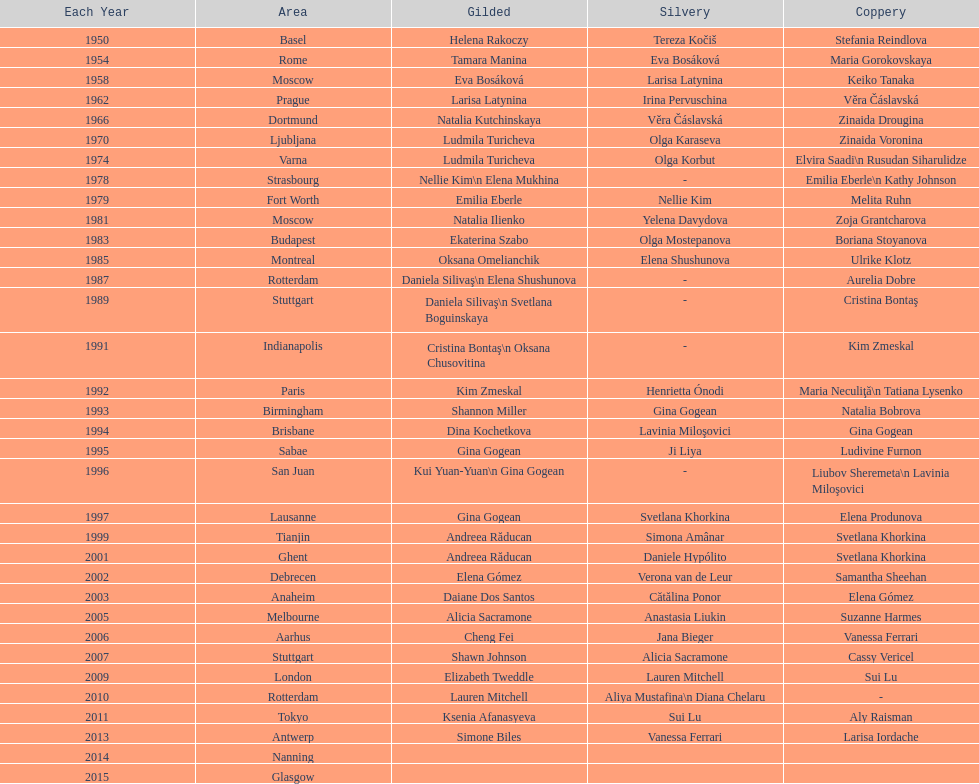As of 2013, what is the total number of floor exercise gold medals won by american women at the world championships? 5. 